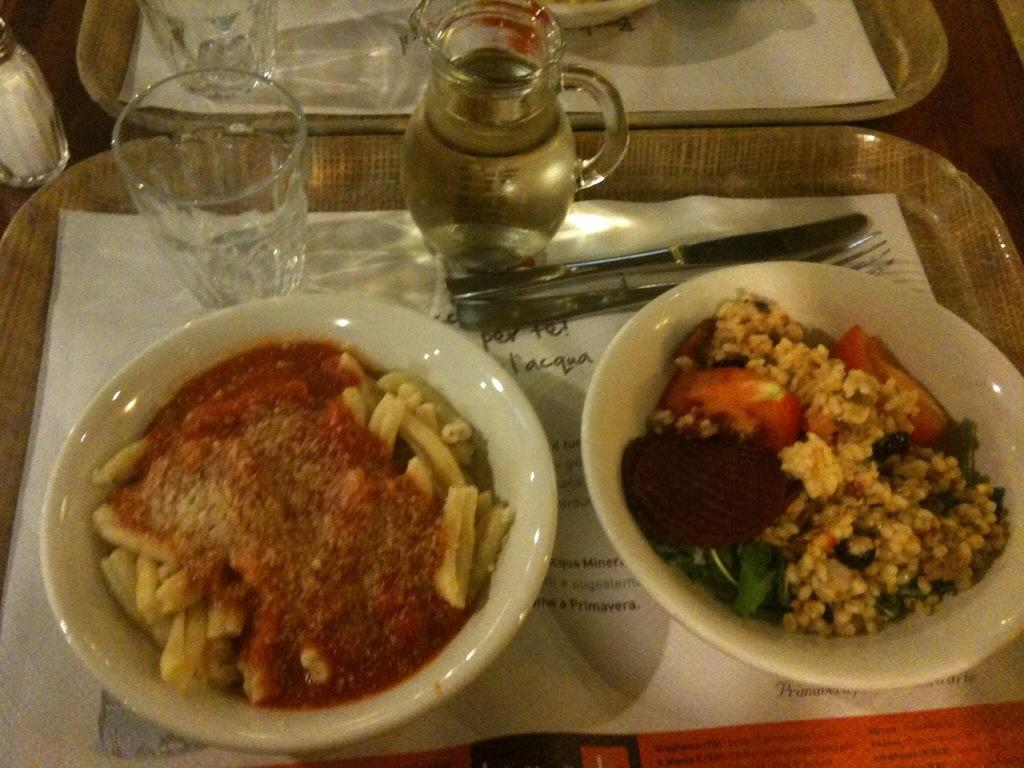What type of food is in the serving bowls in the image? The facts do not specify the type of food in the serving bowls. What can be used for eating the food in the image? Cutlery is visible in the image, which can be used for eating the food. What is the container for drinking in the image? There is a glass tumbler in the image for drinking. What is the container for holding liquid in the image? There is a jug in the image for holding liquid. How are all the items in the image arranged? All the mentioned items are placed on a tray in the image. What type of apparel is the laborer wearing in the image? There is no laborer or apparel present in the image; it only features serving bowls, cutlery, a glass tumbler, and a jug on a tray. 